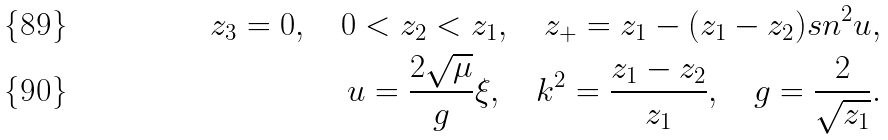Convert formula to latex. <formula><loc_0><loc_0><loc_500><loc_500>z _ { 3 } = 0 , \quad 0 < z _ { 2 } < z _ { 1 } , \quad z _ { + } = z _ { 1 } - ( z _ { 1 } - z _ { 2 } ) { s n } ^ { 2 } u , \\ u = \frac { 2 \sqrt { \mu } } { g } \xi , \quad k ^ { 2 } = \frac { z _ { 1 } - z _ { 2 } } { z _ { 1 } } , \quad g = \frac { 2 } { \sqrt { z _ { 1 } } } .</formula> 